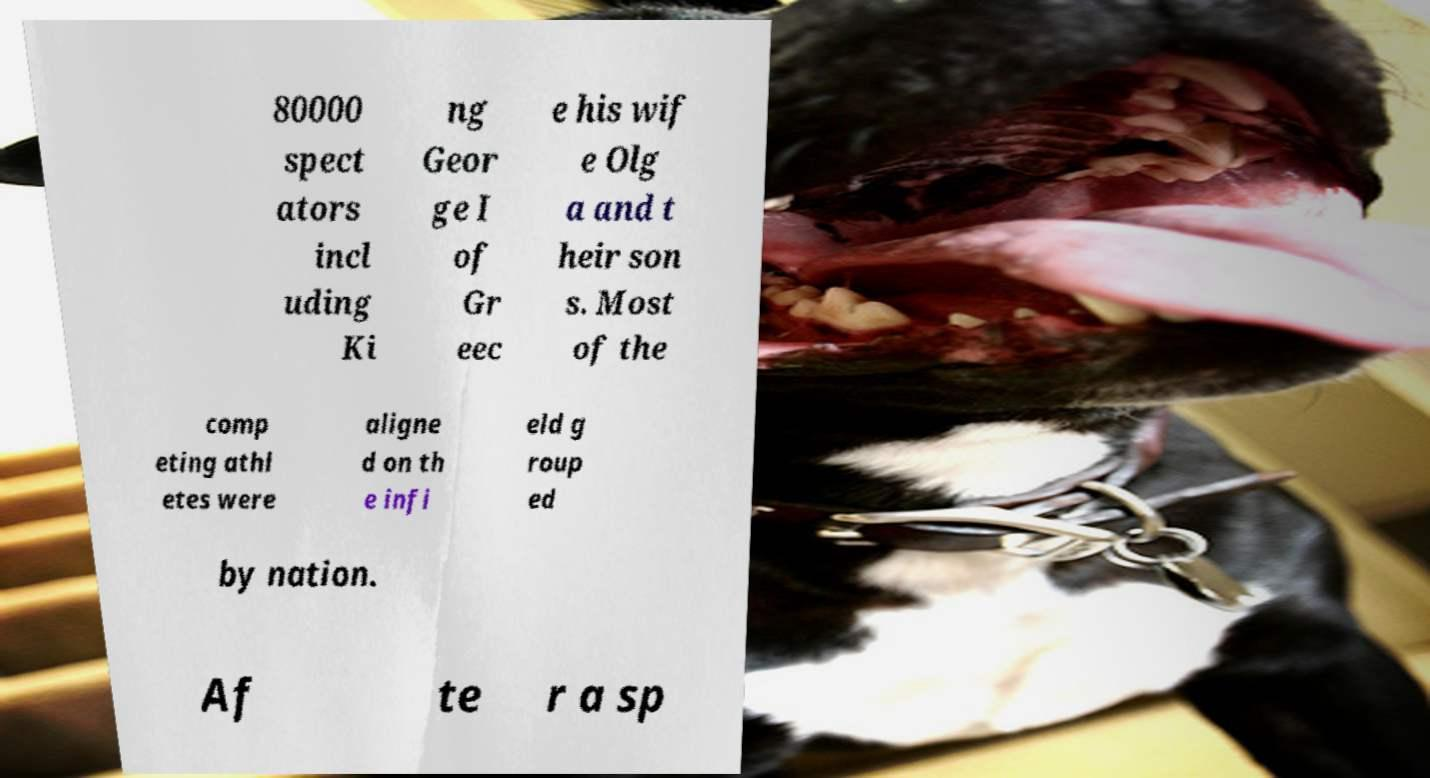I need the written content from this picture converted into text. Can you do that? 80000 spect ators incl uding Ki ng Geor ge I of Gr eec e his wif e Olg a and t heir son s. Most of the comp eting athl etes were aligne d on th e infi eld g roup ed by nation. Af te r a sp 